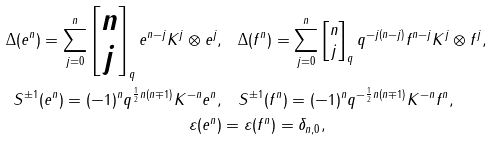<formula> <loc_0><loc_0><loc_500><loc_500>\Delta ( e ^ { n } ) = \sum _ { j = 0 } ^ { n } \begin{bmatrix} n \\ j \end{bmatrix} _ { q } e ^ { n - j } K ^ { j } \otimes e ^ { j } , & \quad \Delta ( f ^ { n } ) = \sum _ { j = 0 } ^ { n } \begin{bmatrix} n \\ j \end{bmatrix} _ { q } q ^ { - j ( n - j ) } f ^ { n - j } K ^ { j } \otimes f ^ { j } , \\ S ^ { \pm 1 } ( e ^ { n } ) = ( - 1 ) ^ { n } q ^ { \frac { 1 } { 2 } n ( n \mp 1 ) } K ^ { - n } e ^ { n } , & \quad S ^ { \pm 1 } ( f ^ { n } ) = ( - 1 ) ^ { n } q ^ { - \frac { 1 } { 2 } n ( n \mp 1 ) } K ^ { - n } f ^ { n } , \\ \varepsilon ( e ^ { n } ) & = \varepsilon ( f ^ { n } ) = \delta _ { n , 0 } ,</formula> 